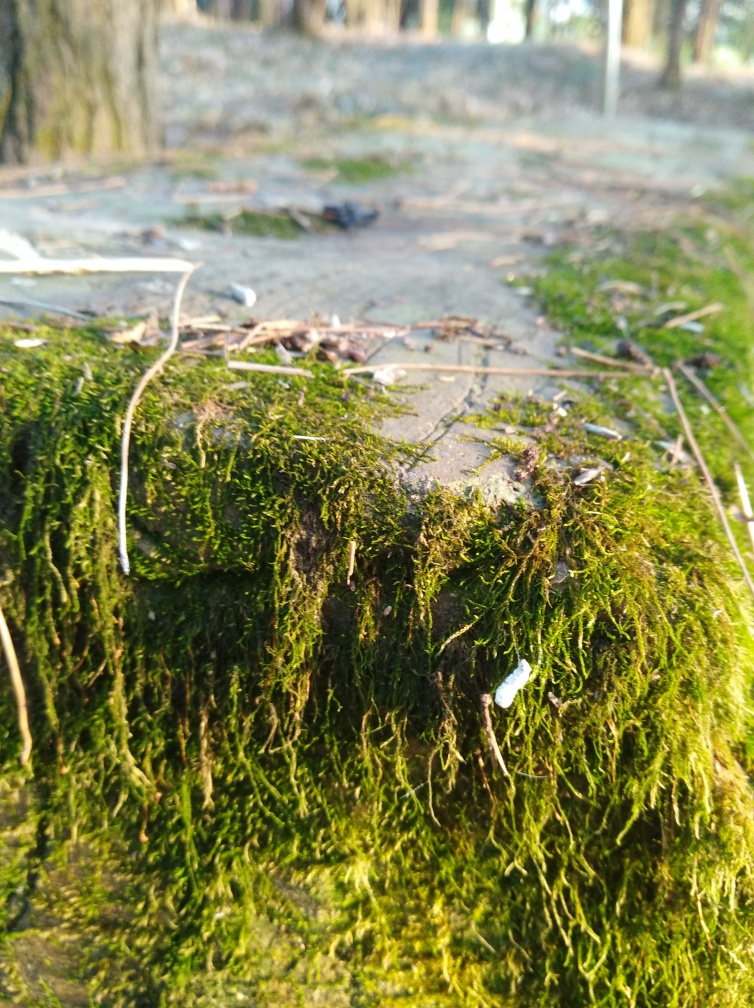Are the texture details of distant houses and the ground lost? In the provided image, the focus appears to be on the moss-covered foreground, which results in the background being out of focus. This causes the texture details of the distant elements, such as any houses or the ground further away, to be less discernible and less sharp compared to the well-defined textures of the moss and the immediate surroundings. 